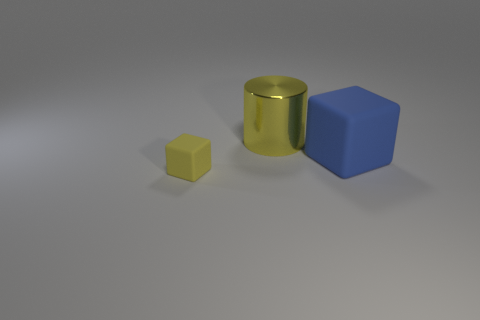Add 1 big blue objects. How many objects exist? 4 Subtract all blocks. How many objects are left? 1 Subtract 0 purple cylinders. How many objects are left? 3 Subtract all metal cylinders. Subtract all big metallic cylinders. How many objects are left? 1 Add 2 big metal cylinders. How many big metal cylinders are left? 3 Add 1 cylinders. How many cylinders exist? 2 